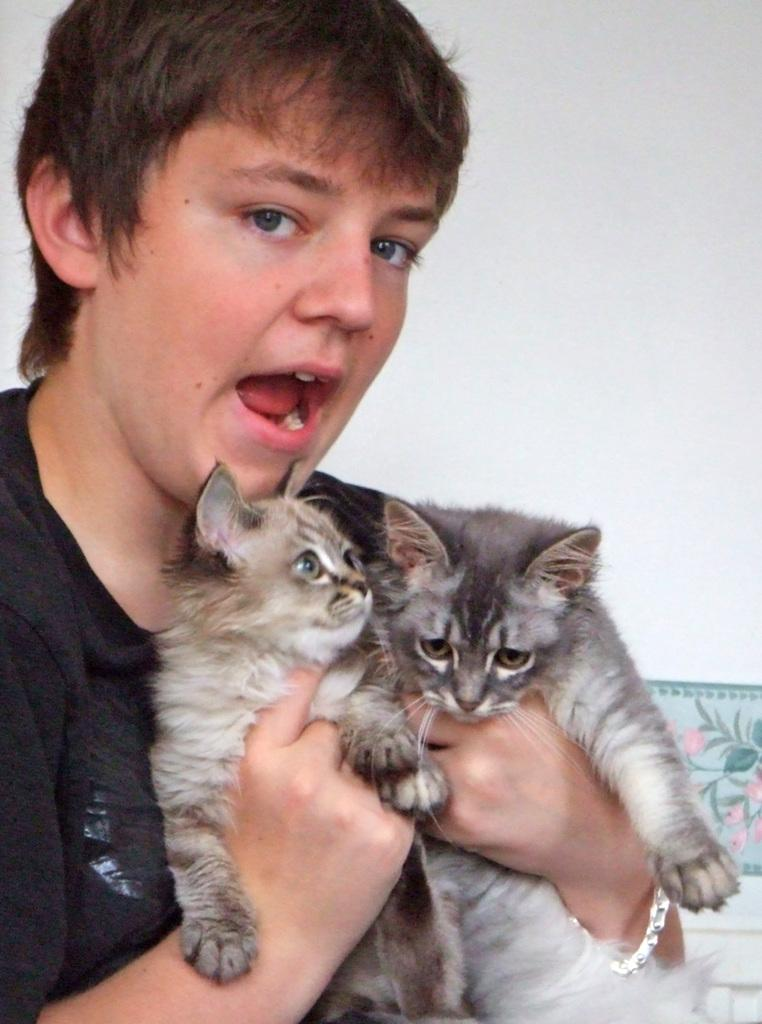What is the main subject of the image? There is a person in the image. What is the person wearing? The person is wearing a black dress. What is the person holding in the image? The person is holding two cats. Can you describe the cats' appearance? The cats are black, cream, and brown in color. What can be seen in the background of the image? There is a white-colored wall in the background of the image. What type of soap is the person using to wash the cats in the image? There is no soap or washing activity depicted in the image; the person is simply holding two cats. Can you see a crown on the person's head in the image? No, there is no crown visible on the person's head in the image. 